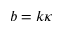<formula> <loc_0><loc_0><loc_500><loc_500>b = k \kappa</formula> 